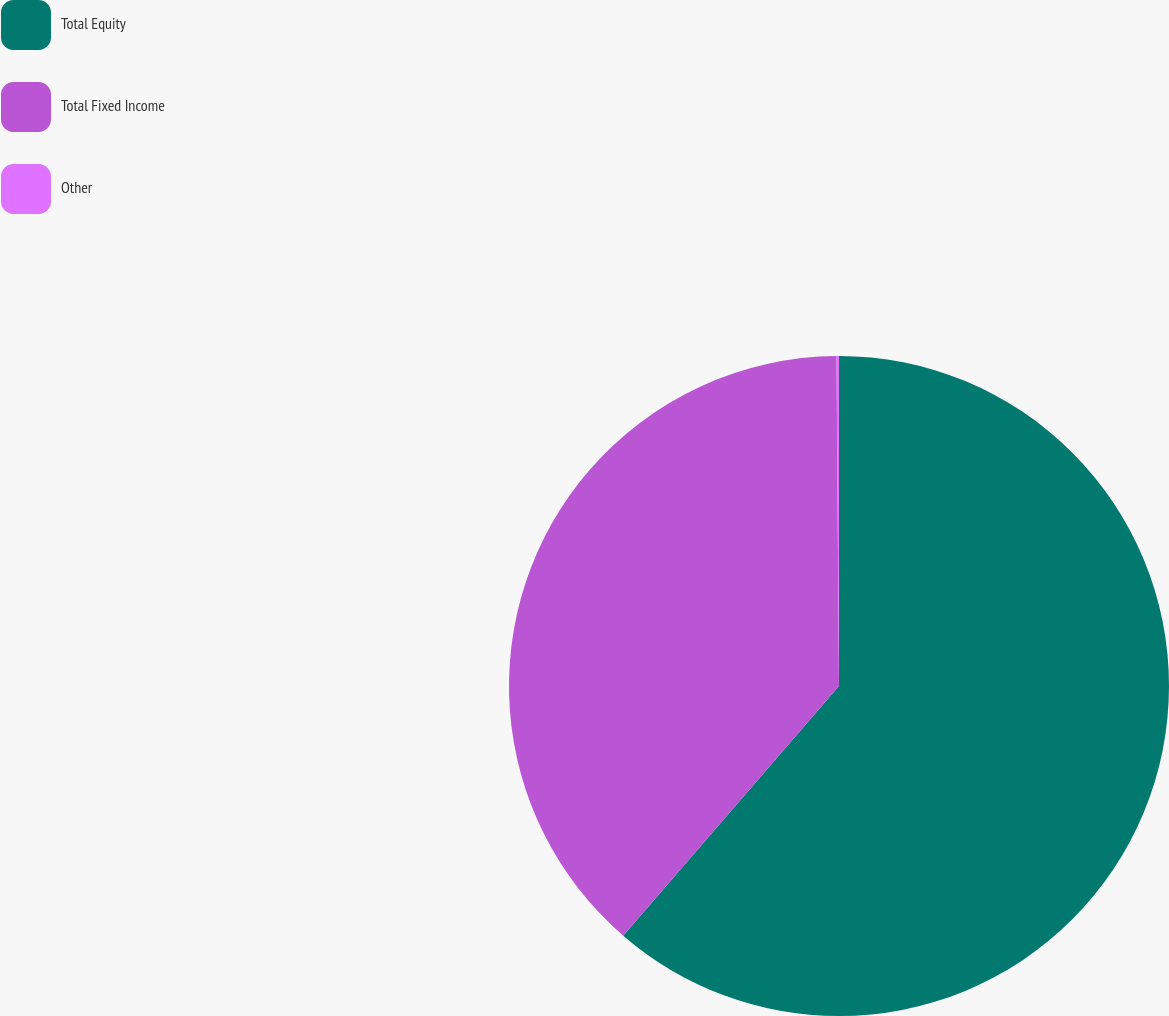Convert chart. <chart><loc_0><loc_0><loc_500><loc_500><pie_chart><fcel>Total Equity<fcel>Total Fixed Income<fcel>Other<nl><fcel>61.35%<fcel>38.54%<fcel>0.12%<nl></chart> 